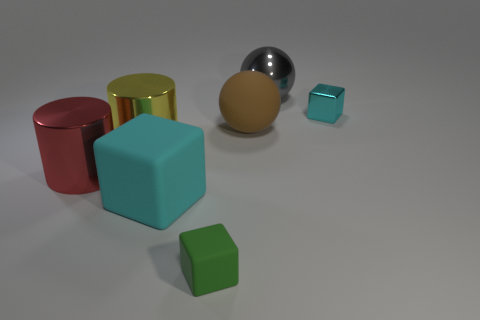How many objects are there in total, and can you describe their shapes and colors? In the image, I see a total of seven objects. From left to right, their shapes and colors are as follows: a red cylinder, a gold cylinder, a brown sphere, a gray metal sphere, a turquoise cube, a small silver cube, and a small green cube. 